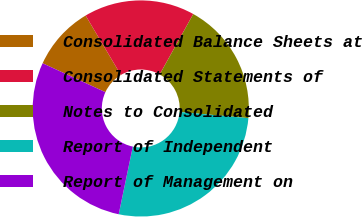Convert chart. <chart><loc_0><loc_0><loc_500><loc_500><pie_chart><fcel>Consolidated Balance Sheets at<fcel>Consolidated Statements of<fcel>Notes to Consolidated<fcel>Report of Independent<fcel>Report of Management on<nl><fcel>9.61%<fcel>16.6%<fcel>18.35%<fcel>26.85%<fcel>28.6%<nl></chart> 